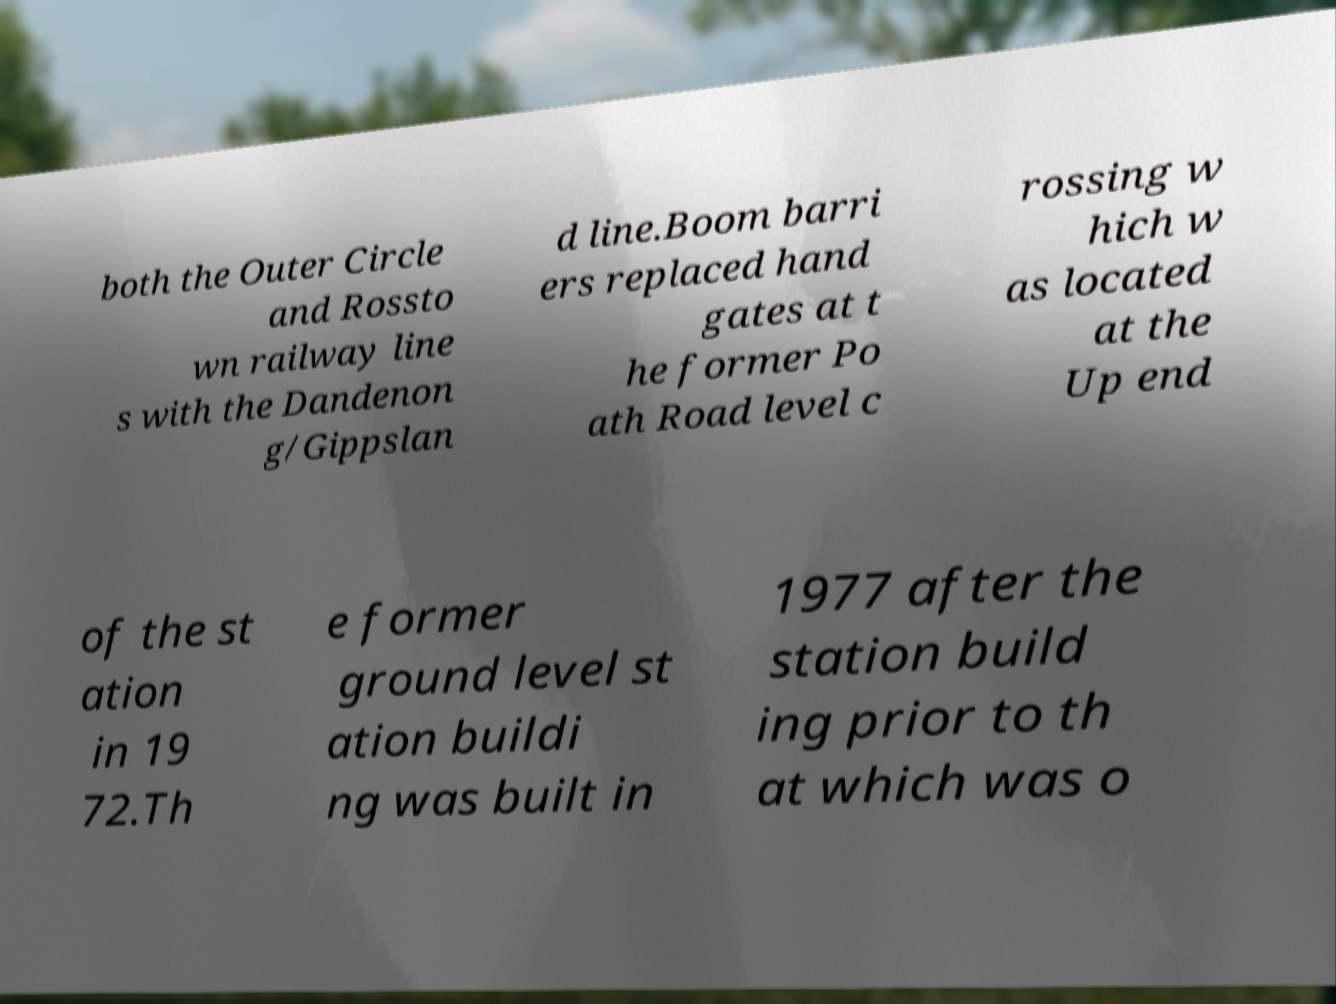Please read and relay the text visible in this image. What does it say? both the Outer Circle and Rossto wn railway line s with the Dandenon g/Gippslan d line.Boom barri ers replaced hand gates at t he former Po ath Road level c rossing w hich w as located at the Up end of the st ation in 19 72.Th e former ground level st ation buildi ng was built in 1977 after the station build ing prior to th at which was o 